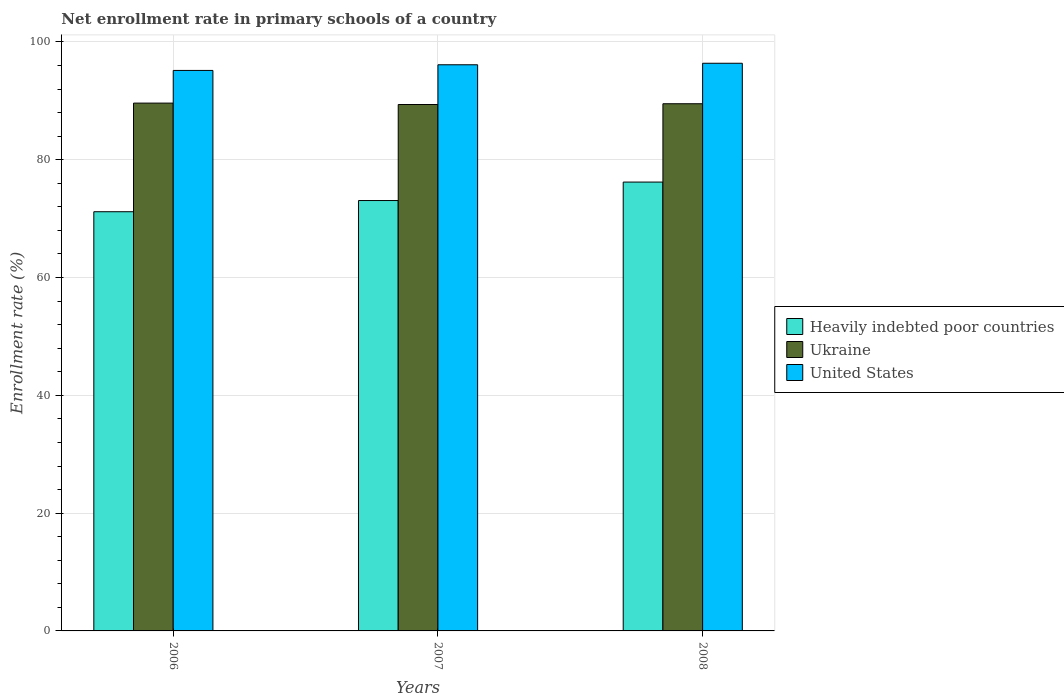How many groups of bars are there?
Your response must be concise. 3. Are the number of bars per tick equal to the number of legend labels?
Provide a short and direct response. Yes. What is the enrollment rate in primary schools in United States in 2006?
Your response must be concise. 95.16. Across all years, what is the maximum enrollment rate in primary schools in Ukraine?
Provide a succinct answer. 89.61. Across all years, what is the minimum enrollment rate in primary schools in United States?
Provide a short and direct response. 95.16. In which year was the enrollment rate in primary schools in United States maximum?
Your response must be concise. 2008. In which year was the enrollment rate in primary schools in Ukraine minimum?
Your answer should be compact. 2007. What is the total enrollment rate in primary schools in Heavily indebted poor countries in the graph?
Keep it short and to the point. 220.45. What is the difference between the enrollment rate in primary schools in Ukraine in 2007 and that in 2008?
Ensure brevity in your answer.  -0.13. What is the difference between the enrollment rate in primary schools in Heavily indebted poor countries in 2007 and the enrollment rate in primary schools in Ukraine in 2006?
Offer a terse response. -16.54. What is the average enrollment rate in primary schools in Ukraine per year?
Make the answer very short. 89.5. In the year 2007, what is the difference between the enrollment rate in primary schools in Heavily indebted poor countries and enrollment rate in primary schools in United States?
Offer a terse response. -23.05. In how many years, is the enrollment rate in primary schools in United States greater than 48 %?
Offer a very short reply. 3. What is the ratio of the enrollment rate in primary schools in Ukraine in 2007 to that in 2008?
Make the answer very short. 1. Is the enrollment rate in primary schools in Heavily indebted poor countries in 2006 less than that in 2008?
Ensure brevity in your answer.  Yes. Is the difference between the enrollment rate in primary schools in Heavily indebted poor countries in 2006 and 2008 greater than the difference between the enrollment rate in primary schools in United States in 2006 and 2008?
Provide a short and direct response. No. What is the difference between the highest and the second highest enrollment rate in primary schools in Heavily indebted poor countries?
Provide a succinct answer. 3.13. What is the difference between the highest and the lowest enrollment rate in primary schools in Heavily indebted poor countries?
Provide a succinct answer. 5.03. In how many years, is the enrollment rate in primary schools in United States greater than the average enrollment rate in primary schools in United States taken over all years?
Offer a very short reply. 2. Is the sum of the enrollment rate in primary schools in Ukraine in 2006 and 2008 greater than the maximum enrollment rate in primary schools in United States across all years?
Give a very brief answer. Yes. What does the 3rd bar from the left in 2008 represents?
Offer a very short reply. United States. What does the 3rd bar from the right in 2006 represents?
Keep it short and to the point. Heavily indebted poor countries. Is it the case that in every year, the sum of the enrollment rate in primary schools in Ukraine and enrollment rate in primary schools in United States is greater than the enrollment rate in primary schools in Heavily indebted poor countries?
Give a very brief answer. Yes. How many bars are there?
Ensure brevity in your answer.  9. Are all the bars in the graph horizontal?
Give a very brief answer. No. How many years are there in the graph?
Your answer should be very brief. 3. Where does the legend appear in the graph?
Keep it short and to the point. Center right. How many legend labels are there?
Offer a very short reply. 3. What is the title of the graph?
Keep it short and to the point. Net enrollment rate in primary schools of a country. Does "Czech Republic" appear as one of the legend labels in the graph?
Provide a succinct answer. No. What is the label or title of the Y-axis?
Offer a very short reply. Enrollment rate (%). What is the Enrollment rate (%) in Heavily indebted poor countries in 2006?
Offer a very short reply. 71.17. What is the Enrollment rate (%) of Ukraine in 2006?
Provide a succinct answer. 89.61. What is the Enrollment rate (%) in United States in 2006?
Ensure brevity in your answer.  95.16. What is the Enrollment rate (%) of Heavily indebted poor countries in 2007?
Keep it short and to the point. 73.07. What is the Enrollment rate (%) of Ukraine in 2007?
Your answer should be compact. 89.37. What is the Enrollment rate (%) in United States in 2007?
Offer a very short reply. 96.12. What is the Enrollment rate (%) of Heavily indebted poor countries in 2008?
Provide a short and direct response. 76.2. What is the Enrollment rate (%) in Ukraine in 2008?
Give a very brief answer. 89.5. What is the Enrollment rate (%) of United States in 2008?
Your answer should be compact. 96.38. Across all years, what is the maximum Enrollment rate (%) in Heavily indebted poor countries?
Make the answer very short. 76.2. Across all years, what is the maximum Enrollment rate (%) of Ukraine?
Offer a very short reply. 89.61. Across all years, what is the maximum Enrollment rate (%) in United States?
Keep it short and to the point. 96.38. Across all years, what is the minimum Enrollment rate (%) of Heavily indebted poor countries?
Provide a succinct answer. 71.17. Across all years, what is the minimum Enrollment rate (%) in Ukraine?
Your response must be concise. 89.37. Across all years, what is the minimum Enrollment rate (%) of United States?
Your answer should be compact. 95.16. What is the total Enrollment rate (%) of Heavily indebted poor countries in the graph?
Ensure brevity in your answer.  220.44. What is the total Enrollment rate (%) in Ukraine in the graph?
Provide a succinct answer. 268.49. What is the total Enrollment rate (%) in United States in the graph?
Your response must be concise. 287.66. What is the difference between the Enrollment rate (%) in Heavily indebted poor countries in 2006 and that in 2007?
Give a very brief answer. -1.9. What is the difference between the Enrollment rate (%) of Ukraine in 2006 and that in 2007?
Give a very brief answer. 0.24. What is the difference between the Enrollment rate (%) of United States in 2006 and that in 2007?
Make the answer very short. -0.96. What is the difference between the Enrollment rate (%) of Heavily indebted poor countries in 2006 and that in 2008?
Your answer should be very brief. -5.03. What is the difference between the Enrollment rate (%) in Ukraine in 2006 and that in 2008?
Your answer should be compact. 0.11. What is the difference between the Enrollment rate (%) of United States in 2006 and that in 2008?
Ensure brevity in your answer.  -1.22. What is the difference between the Enrollment rate (%) of Heavily indebted poor countries in 2007 and that in 2008?
Offer a very short reply. -3.13. What is the difference between the Enrollment rate (%) in Ukraine in 2007 and that in 2008?
Provide a succinct answer. -0.13. What is the difference between the Enrollment rate (%) in United States in 2007 and that in 2008?
Offer a terse response. -0.26. What is the difference between the Enrollment rate (%) of Heavily indebted poor countries in 2006 and the Enrollment rate (%) of Ukraine in 2007?
Provide a short and direct response. -18.2. What is the difference between the Enrollment rate (%) in Heavily indebted poor countries in 2006 and the Enrollment rate (%) in United States in 2007?
Provide a short and direct response. -24.95. What is the difference between the Enrollment rate (%) of Ukraine in 2006 and the Enrollment rate (%) of United States in 2007?
Keep it short and to the point. -6.51. What is the difference between the Enrollment rate (%) of Heavily indebted poor countries in 2006 and the Enrollment rate (%) of Ukraine in 2008?
Offer a terse response. -18.33. What is the difference between the Enrollment rate (%) of Heavily indebted poor countries in 2006 and the Enrollment rate (%) of United States in 2008?
Keep it short and to the point. -25.21. What is the difference between the Enrollment rate (%) of Ukraine in 2006 and the Enrollment rate (%) of United States in 2008?
Provide a succinct answer. -6.77. What is the difference between the Enrollment rate (%) in Heavily indebted poor countries in 2007 and the Enrollment rate (%) in Ukraine in 2008?
Your answer should be compact. -16.43. What is the difference between the Enrollment rate (%) of Heavily indebted poor countries in 2007 and the Enrollment rate (%) of United States in 2008?
Provide a succinct answer. -23.31. What is the difference between the Enrollment rate (%) in Ukraine in 2007 and the Enrollment rate (%) in United States in 2008?
Provide a succinct answer. -7. What is the average Enrollment rate (%) of Heavily indebted poor countries per year?
Provide a succinct answer. 73.48. What is the average Enrollment rate (%) of Ukraine per year?
Your response must be concise. 89.5. What is the average Enrollment rate (%) in United States per year?
Offer a terse response. 95.89. In the year 2006, what is the difference between the Enrollment rate (%) in Heavily indebted poor countries and Enrollment rate (%) in Ukraine?
Your response must be concise. -18.44. In the year 2006, what is the difference between the Enrollment rate (%) in Heavily indebted poor countries and Enrollment rate (%) in United States?
Provide a succinct answer. -23.99. In the year 2006, what is the difference between the Enrollment rate (%) of Ukraine and Enrollment rate (%) of United States?
Provide a succinct answer. -5.55. In the year 2007, what is the difference between the Enrollment rate (%) of Heavily indebted poor countries and Enrollment rate (%) of Ukraine?
Offer a terse response. -16.3. In the year 2007, what is the difference between the Enrollment rate (%) of Heavily indebted poor countries and Enrollment rate (%) of United States?
Your answer should be very brief. -23.05. In the year 2007, what is the difference between the Enrollment rate (%) of Ukraine and Enrollment rate (%) of United States?
Offer a terse response. -6.74. In the year 2008, what is the difference between the Enrollment rate (%) of Heavily indebted poor countries and Enrollment rate (%) of Ukraine?
Your response must be concise. -13.3. In the year 2008, what is the difference between the Enrollment rate (%) in Heavily indebted poor countries and Enrollment rate (%) in United States?
Offer a very short reply. -20.17. In the year 2008, what is the difference between the Enrollment rate (%) in Ukraine and Enrollment rate (%) in United States?
Give a very brief answer. -6.87. What is the ratio of the Enrollment rate (%) of Heavily indebted poor countries in 2006 to that in 2007?
Give a very brief answer. 0.97. What is the ratio of the Enrollment rate (%) of Ukraine in 2006 to that in 2007?
Your response must be concise. 1. What is the ratio of the Enrollment rate (%) of Heavily indebted poor countries in 2006 to that in 2008?
Offer a very short reply. 0.93. What is the ratio of the Enrollment rate (%) in United States in 2006 to that in 2008?
Offer a very short reply. 0.99. What is the ratio of the Enrollment rate (%) of Heavily indebted poor countries in 2007 to that in 2008?
Offer a very short reply. 0.96. What is the ratio of the Enrollment rate (%) of United States in 2007 to that in 2008?
Give a very brief answer. 1. What is the difference between the highest and the second highest Enrollment rate (%) of Heavily indebted poor countries?
Your answer should be compact. 3.13. What is the difference between the highest and the second highest Enrollment rate (%) in Ukraine?
Offer a very short reply. 0.11. What is the difference between the highest and the second highest Enrollment rate (%) in United States?
Ensure brevity in your answer.  0.26. What is the difference between the highest and the lowest Enrollment rate (%) in Heavily indebted poor countries?
Your answer should be very brief. 5.03. What is the difference between the highest and the lowest Enrollment rate (%) in Ukraine?
Give a very brief answer. 0.24. What is the difference between the highest and the lowest Enrollment rate (%) in United States?
Your response must be concise. 1.22. 